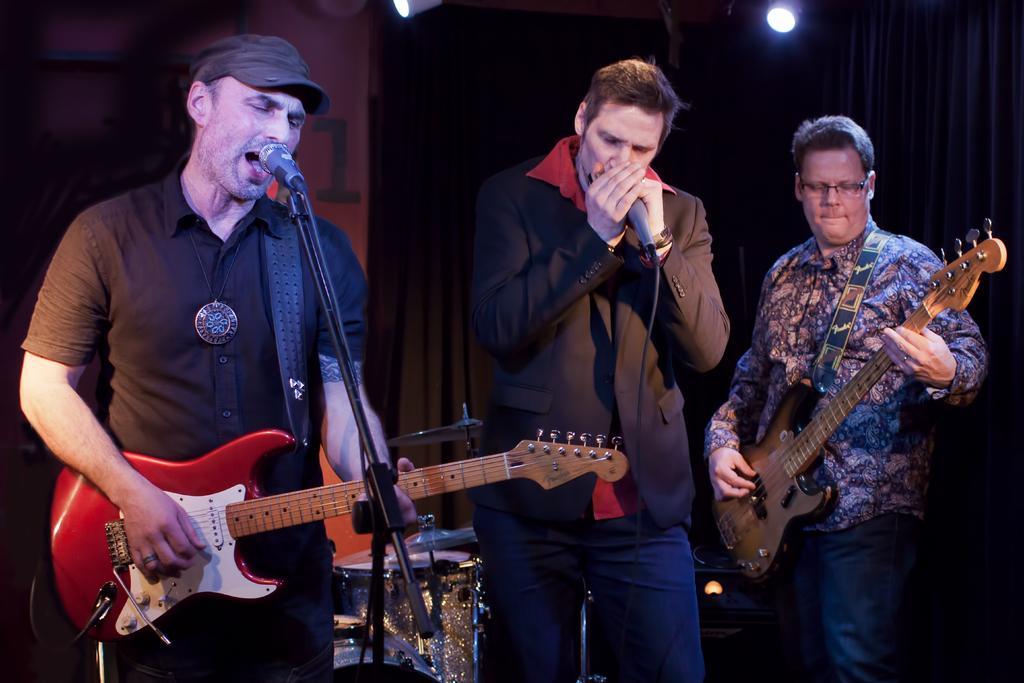Describe this image in one or two sentences. Here in this picture coming from the right we can see a person playing guitar and in the middle the person is singing a song with microphone in his hand the person on the left is playing a guitar and singing a song with microphone in front of him and behind them we can see drums and we can see lights present at the top 